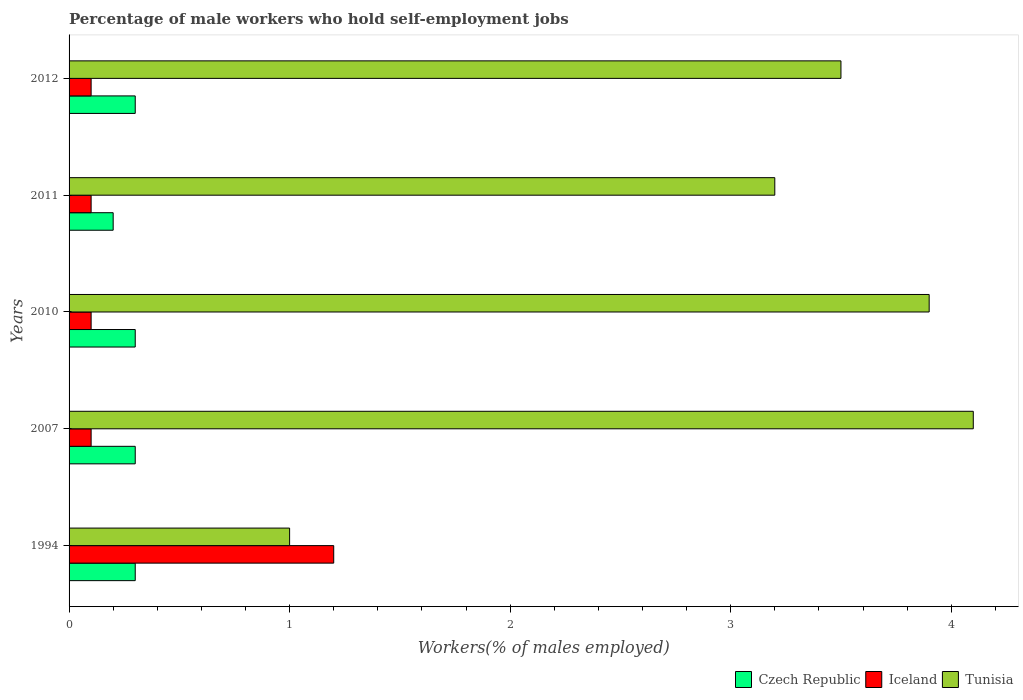How many groups of bars are there?
Ensure brevity in your answer.  5. Are the number of bars on each tick of the Y-axis equal?
Give a very brief answer. Yes. How many bars are there on the 5th tick from the top?
Provide a short and direct response. 3. What is the label of the 1st group of bars from the top?
Ensure brevity in your answer.  2012. In how many cases, is the number of bars for a given year not equal to the number of legend labels?
Ensure brevity in your answer.  0. What is the percentage of self-employed male workers in Tunisia in 2007?
Provide a short and direct response. 4.1. Across all years, what is the maximum percentage of self-employed male workers in Czech Republic?
Your answer should be very brief. 0.3. Across all years, what is the minimum percentage of self-employed male workers in Iceland?
Give a very brief answer. 0.1. In which year was the percentage of self-employed male workers in Iceland minimum?
Your answer should be very brief. 2007. What is the total percentage of self-employed male workers in Tunisia in the graph?
Your answer should be compact. 15.7. What is the difference between the percentage of self-employed male workers in Tunisia in 2007 and that in 2011?
Offer a terse response. 0.9. What is the difference between the percentage of self-employed male workers in Tunisia in 2010 and the percentage of self-employed male workers in Iceland in 2011?
Give a very brief answer. 3.8. What is the average percentage of self-employed male workers in Tunisia per year?
Provide a succinct answer. 3.14. In the year 2011, what is the difference between the percentage of self-employed male workers in Iceland and percentage of self-employed male workers in Czech Republic?
Give a very brief answer. -0.1. In how many years, is the percentage of self-employed male workers in Iceland greater than 1.6 %?
Keep it short and to the point. 0. What is the ratio of the percentage of self-employed male workers in Tunisia in 2010 to that in 2011?
Keep it short and to the point. 1.22. Is the difference between the percentage of self-employed male workers in Iceland in 2007 and 2011 greater than the difference between the percentage of self-employed male workers in Czech Republic in 2007 and 2011?
Your answer should be very brief. No. What is the difference between the highest and the second highest percentage of self-employed male workers in Tunisia?
Keep it short and to the point. 0.2. What is the difference between the highest and the lowest percentage of self-employed male workers in Czech Republic?
Ensure brevity in your answer.  0.1. In how many years, is the percentage of self-employed male workers in Czech Republic greater than the average percentage of self-employed male workers in Czech Republic taken over all years?
Offer a very short reply. 4. Is the sum of the percentage of self-employed male workers in Iceland in 1994 and 2011 greater than the maximum percentage of self-employed male workers in Czech Republic across all years?
Offer a very short reply. Yes. What does the 1st bar from the top in 2007 represents?
Keep it short and to the point. Tunisia. What does the 1st bar from the bottom in 1994 represents?
Keep it short and to the point. Czech Republic. How many bars are there?
Your answer should be compact. 15. Are all the bars in the graph horizontal?
Ensure brevity in your answer.  Yes. What is the difference between two consecutive major ticks on the X-axis?
Keep it short and to the point. 1. Does the graph contain any zero values?
Your response must be concise. No. Does the graph contain grids?
Make the answer very short. No. Where does the legend appear in the graph?
Provide a succinct answer. Bottom right. How are the legend labels stacked?
Your response must be concise. Horizontal. What is the title of the graph?
Give a very brief answer. Percentage of male workers who hold self-employment jobs. Does "Bolivia" appear as one of the legend labels in the graph?
Offer a terse response. No. What is the label or title of the X-axis?
Ensure brevity in your answer.  Workers(% of males employed). What is the Workers(% of males employed) of Czech Republic in 1994?
Make the answer very short. 0.3. What is the Workers(% of males employed) of Iceland in 1994?
Provide a short and direct response. 1.2. What is the Workers(% of males employed) in Czech Republic in 2007?
Make the answer very short. 0.3. What is the Workers(% of males employed) in Iceland in 2007?
Provide a short and direct response. 0.1. What is the Workers(% of males employed) in Tunisia in 2007?
Provide a short and direct response. 4.1. What is the Workers(% of males employed) in Czech Republic in 2010?
Your answer should be compact. 0.3. What is the Workers(% of males employed) of Iceland in 2010?
Your answer should be compact. 0.1. What is the Workers(% of males employed) of Tunisia in 2010?
Your response must be concise. 3.9. What is the Workers(% of males employed) in Czech Republic in 2011?
Make the answer very short. 0.2. What is the Workers(% of males employed) of Iceland in 2011?
Provide a short and direct response. 0.1. What is the Workers(% of males employed) in Tunisia in 2011?
Keep it short and to the point. 3.2. What is the Workers(% of males employed) in Czech Republic in 2012?
Your answer should be compact. 0.3. What is the Workers(% of males employed) of Iceland in 2012?
Ensure brevity in your answer.  0.1. Across all years, what is the maximum Workers(% of males employed) in Czech Republic?
Keep it short and to the point. 0.3. Across all years, what is the maximum Workers(% of males employed) in Iceland?
Provide a succinct answer. 1.2. Across all years, what is the maximum Workers(% of males employed) in Tunisia?
Your response must be concise. 4.1. Across all years, what is the minimum Workers(% of males employed) of Czech Republic?
Your answer should be very brief. 0.2. Across all years, what is the minimum Workers(% of males employed) in Iceland?
Ensure brevity in your answer.  0.1. Across all years, what is the minimum Workers(% of males employed) in Tunisia?
Your answer should be compact. 1. What is the total Workers(% of males employed) of Tunisia in the graph?
Provide a succinct answer. 15.7. What is the difference between the Workers(% of males employed) of Iceland in 1994 and that in 2007?
Offer a very short reply. 1.1. What is the difference between the Workers(% of males employed) of Tunisia in 1994 and that in 2007?
Provide a short and direct response. -3.1. What is the difference between the Workers(% of males employed) in Czech Republic in 1994 and that in 2010?
Offer a very short reply. 0. What is the difference between the Workers(% of males employed) in Iceland in 1994 and that in 2011?
Your answer should be compact. 1.1. What is the difference between the Workers(% of males employed) in Iceland in 1994 and that in 2012?
Keep it short and to the point. 1.1. What is the difference between the Workers(% of males employed) of Tunisia in 1994 and that in 2012?
Provide a short and direct response. -2.5. What is the difference between the Workers(% of males employed) in Czech Republic in 2007 and that in 2010?
Offer a very short reply. 0. What is the difference between the Workers(% of males employed) of Iceland in 2007 and that in 2010?
Your answer should be compact. 0. What is the difference between the Workers(% of males employed) of Czech Republic in 2007 and that in 2011?
Offer a terse response. 0.1. What is the difference between the Workers(% of males employed) in Tunisia in 2007 and that in 2011?
Give a very brief answer. 0.9. What is the difference between the Workers(% of males employed) of Czech Republic in 2007 and that in 2012?
Give a very brief answer. 0. What is the difference between the Workers(% of males employed) of Czech Republic in 2010 and that in 2011?
Offer a very short reply. 0.1. What is the difference between the Workers(% of males employed) of Czech Republic in 2010 and that in 2012?
Your answer should be very brief. 0. What is the difference between the Workers(% of males employed) in Iceland in 2010 and that in 2012?
Offer a terse response. 0. What is the difference between the Workers(% of males employed) in Iceland in 2011 and that in 2012?
Make the answer very short. 0. What is the difference between the Workers(% of males employed) of Czech Republic in 1994 and the Workers(% of males employed) of Iceland in 2007?
Provide a short and direct response. 0.2. What is the difference between the Workers(% of males employed) in Czech Republic in 1994 and the Workers(% of males employed) in Tunisia in 2007?
Make the answer very short. -3.8. What is the difference between the Workers(% of males employed) in Iceland in 1994 and the Workers(% of males employed) in Tunisia in 2007?
Give a very brief answer. -2.9. What is the difference between the Workers(% of males employed) in Czech Republic in 1994 and the Workers(% of males employed) in Iceland in 2010?
Ensure brevity in your answer.  0.2. What is the difference between the Workers(% of males employed) in Czech Republic in 1994 and the Workers(% of males employed) in Tunisia in 2010?
Make the answer very short. -3.6. What is the difference between the Workers(% of males employed) in Czech Republic in 1994 and the Workers(% of males employed) in Iceland in 2011?
Give a very brief answer. 0.2. What is the difference between the Workers(% of males employed) of Iceland in 1994 and the Workers(% of males employed) of Tunisia in 2011?
Your response must be concise. -2. What is the difference between the Workers(% of males employed) in Czech Republic in 1994 and the Workers(% of males employed) in Iceland in 2012?
Offer a terse response. 0.2. What is the difference between the Workers(% of males employed) of Iceland in 1994 and the Workers(% of males employed) of Tunisia in 2012?
Your answer should be compact. -2.3. What is the difference between the Workers(% of males employed) in Czech Republic in 2007 and the Workers(% of males employed) in Tunisia in 2010?
Your answer should be compact. -3.6. What is the difference between the Workers(% of males employed) in Iceland in 2007 and the Workers(% of males employed) in Tunisia in 2011?
Keep it short and to the point. -3.1. What is the difference between the Workers(% of males employed) in Iceland in 2007 and the Workers(% of males employed) in Tunisia in 2012?
Ensure brevity in your answer.  -3.4. What is the difference between the Workers(% of males employed) of Czech Republic in 2010 and the Workers(% of males employed) of Tunisia in 2011?
Keep it short and to the point. -2.9. What is the difference between the Workers(% of males employed) in Iceland in 2010 and the Workers(% of males employed) in Tunisia in 2011?
Your response must be concise. -3.1. What is the difference between the Workers(% of males employed) in Czech Republic in 2011 and the Workers(% of males employed) in Iceland in 2012?
Your response must be concise. 0.1. What is the average Workers(% of males employed) in Czech Republic per year?
Make the answer very short. 0.28. What is the average Workers(% of males employed) of Iceland per year?
Offer a very short reply. 0.32. What is the average Workers(% of males employed) in Tunisia per year?
Keep it short and to the point. 3.14. In the year 1994, what is the difference between the Workers(% of males employed) of Iceland and Workers(% of males employed) of Tunisia?
Offer a very short reply. 0.2. In the year 2007, what is the difference between the Workers(% of males employed) of Czech Republic and Workers(% of males employed) of Iceland?
Your answer should be very brief. 0.2. In the year 2007, what is the difference between the Workers(% of males employed) of Czech Republic and Workers(% of males employed) of Tunisia?
Your answer should be very brief. -3.8. In the year 2010, what is the difference between the Workers(% of males employed) of Czech Republic and Workers(% of males employed) of Iceland?
Give a very brief answer. 0.2. In the year 2011, what is the difference between the Workers(% of males employed) of Czech Republic and Workers(% of males employed) of Iceland?
Your response must be concise. 0.1. In the year 2012, what is the difference between the Workers(% of males employed) in Czech Republic and Workers(% of males employed) in Iceland?
Offer a terse response. 0.2. In the year 2012, what is the difference between the Workers(% of males employed) in Iceland and Workers(% of males employed) in Tunisia?
Your answer should be compact. -3.4. What is the ratio of the Workers(% of males employed) of Czech Republic in 1994 to that in 2007?
Give a very brief answer. 1. What is the ratio of the Workers(% of males employed) of Iceland in 1994 to that in 2007?
Your answer should be compact. 12. What is the ratio of the Workers(% of males employed) of Tunisia in 1994 to that in 2007?
Offer a very short reply. 0.24. What is the ratio of the Workers(% of males employed) of Iceland in 1994 to that in 2010?
Provide a short and direct response. 12. What is the ratio of the Workers(% of males employed) of Tunisia in 1994 to that in 2010?
Offer a terse response. 0.26. What is the ratio of the Workers(% of males employed) of Czech Republic in 1994 to that in 2011?
Provide a succinct answer. 1.5. What is the ratio of the Workers(% of males employed) of Iceland in 1994 to that in 2011?
Provide a succinct answer. 12. What is the ratio of the Workers(% of males employed) of Tunisia in 1994 to that in 2011?
Ensure brevity in your answer.  0.31. What is the ratio of the Workers(% of males employed) of Czech Republic in 1994 to that in 2012?
Keep it short and to the point. 1. What is the ratio of the Workers(% of males employed) of Tunisia in 1994 to that in 2012?
Offer a terse response. 0.29. What is the ratio of the Workers(% of males employed) of Iceland in 2007 to that in 2010?
Keep it short and to the point. 1. What is the ratio of the Workers(% of males employed) of Tunisia in 2007 to that in 2010?
Provide a succinct answer. 1.05. What is the ratio of the Workers(% of males employed) in Czech Republic in 2007 to that in 2011?
Keep it short and to the point. 1.5. What is the ratio of the Workers(% of males employed) of Iceland in 2007 to that in 2011?
Ensure brevity in your answer.  1. What is the ratio of the Workers(% of males employed) in Tunisia in 2007 to that in 2011?
Offer a very short reply. 1.28. What is the ratio of the Workers(% of males employed) in Czech Republic in 2007 to that in 2012?
Provide a short and direct response. 1. What is the ratio of the Workers(% of males employed) of Tunisia in 2007 to that in 2012?
Offer a terse response. 1.17. What is the ratio of the Workers(% of males employed) in Czech Republic in 2010 to that in 2011?
Your answer should be compact. 1.5. What is the ratio of the Workers(% of males employed) in Tunisia in 2010 to that in 2011?
Your answer should be very brief. 1.22. What is the ratio of the Workers(% of males employed) of Iceland in 2010 to that in 2012?
Offer a very short reply. 1. What is the ratio of the Workers(% of males employed) in Tunisia in 2010 to that in 2012?
Your answer should be very brief. 1.11. What is the ratio of the Workers(% of males employed) in Czech Republic in 2011 to that in 2012?
Your answer should be very brief. 0.67. What is the ratio of the Workers(% of males employed) of Tunisia in 2011 to that in 2012?
Your response must be concise. 0.91. What is the difference between the highest and the second highest Workers(% of males employed) of Czech Republic?
Offer a terse response. 0. What is the difference between the highest and the second highest Workers(% of males employed) in Iceland?
Ensure brevity in your answer.  1.1. What is the difference between the highest and the lowest Workers(% of males employed) in Czech Republic?
Ensure brevity in your answer.  0.1. What is the difference between the highest and the lowest Workers(% of males employed) of Tunisia?
Keep it short and to the point. 3.1. 